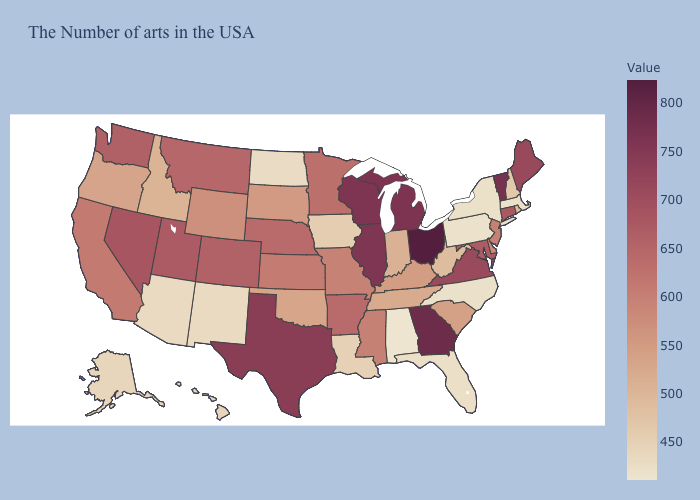Does Wyoming have a higher value than Maine?
Write a very short answer. No. Does Indiana have a higher value than Montana?
Answer briefly. No. Which states have the lowest value in the West?
Answer briefly. New Mexico. Does the map have missing data?
Keep it brief. No. Which states have the lowest value in the USA?
Quick response, please. Alabama. Does Alabama have the lowest value in the USA?
Give a very brief answer. Yes. 